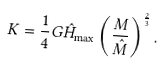<formula> <loc_0><loc_0><loc_500><loc_500>K = \frac { 1 } { 4 } G \hat { H } _ { \max } \left ( \frac { M } { \hat { M } } \right ) ^ { \frac { 2 } { 3 } } .</formula> 